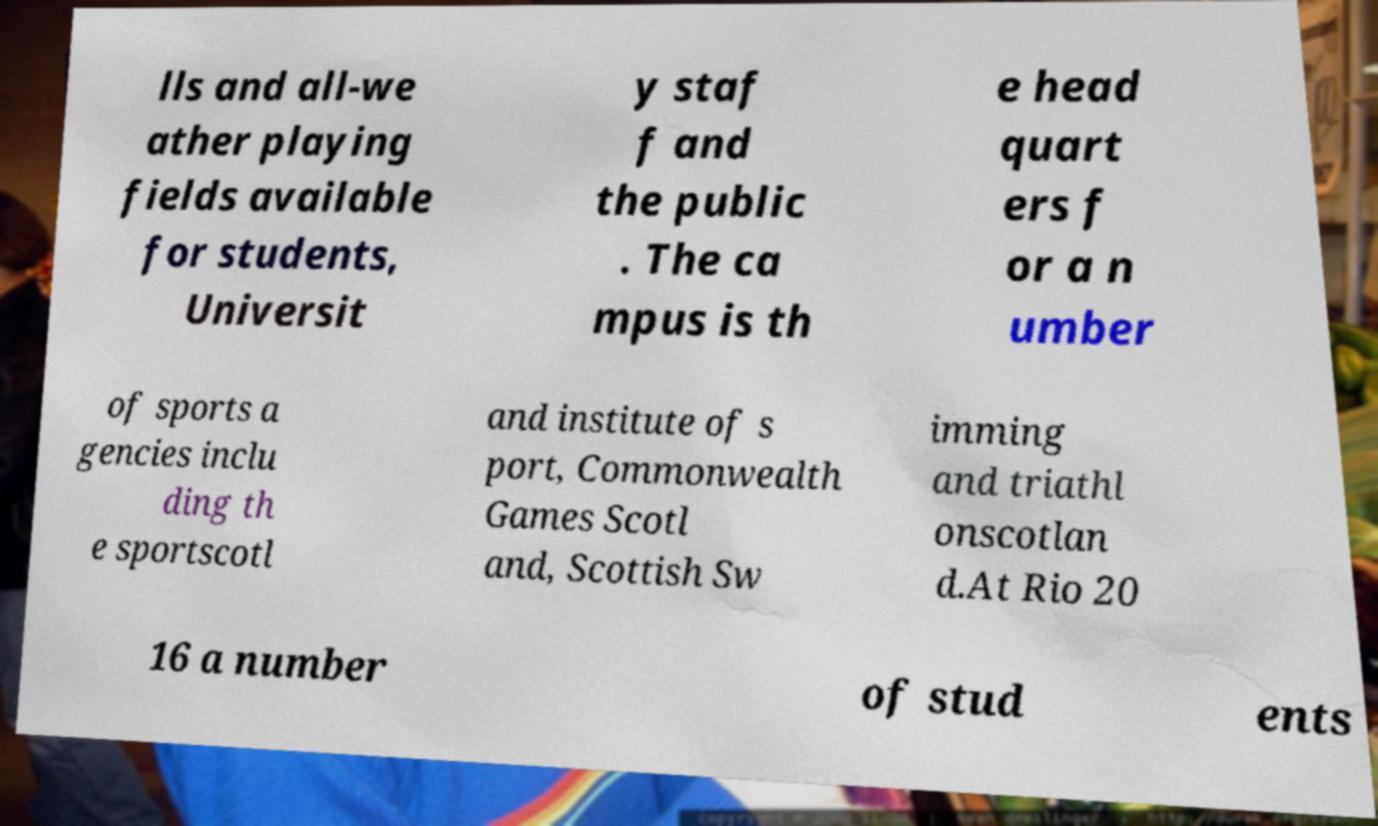Please read and relay the text visible in this image. What does it say? lls and all-we ather playing fields available for students, Universit y staf f and the public . The ca mpus is th e head quart ers f or a n umber of sports a gencies inclu ding th e sportscotl and institute of s port, Commonwealth Games Scotl and, Scottish Sw imming and triathl onscotlan d.At Rio 20 16 a number of stud ents 